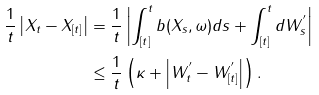<formula> <loc_0><loc_0><loc_500><loc_500>\frac { 1 } { t } \left | X _ { t } - X _ { [ t ] } \right | & = \frac { 1 } { t } \left | \int _ { [ t ] } ^ { t } b ( X _ { s } , \omega ) d s + \int _ { [ t ] } ^ { t } d W ^ { ^ { \prime } } _ { s } \right | \\ & \leq \frac { 1 } { t } \left ( \kappa + \left | W ^ { ^ { \prime } } _ { t } - W ^ { ^ { \prime } } _ { [ t ] } \right | \right ) .</formula> 